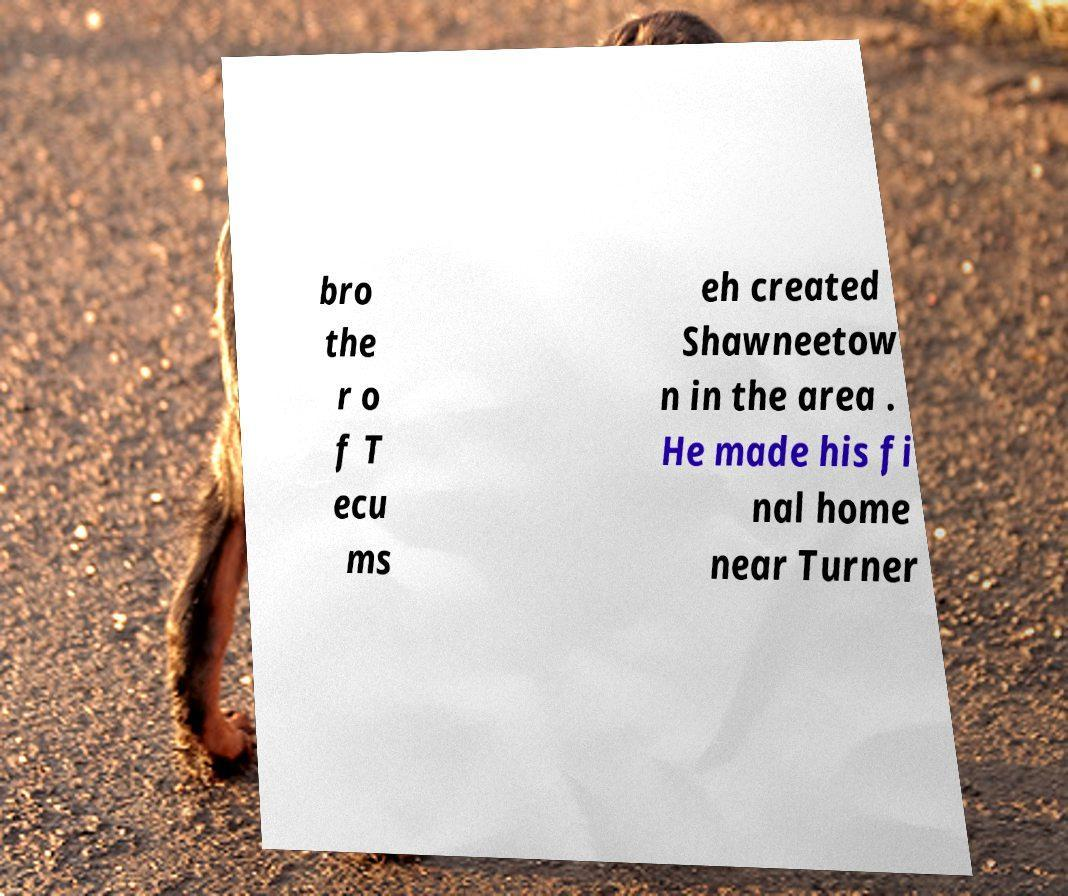Can you read and provide the text displayed in the image?This photo seems to have some interesting text. Can you extract and type it out for me? bro the r o f T ecu ms eh created Shawneetow n in the area . He made his fi nal home near Turner 